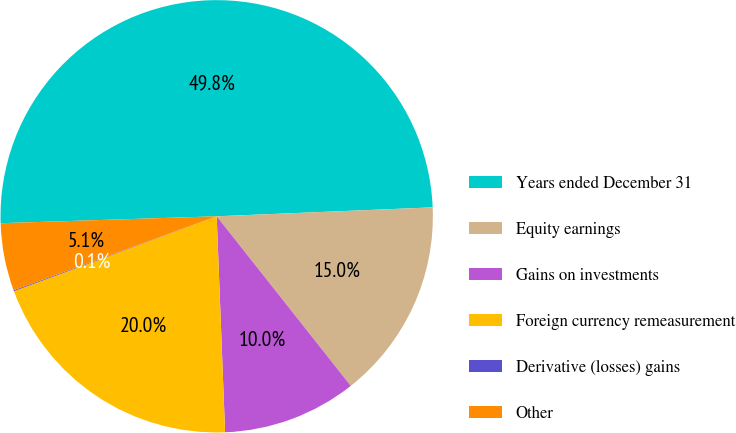<chart> <loc_0><loc_0><loc_500><loc_500><pie_chart><fcel>Years ended December 31<fcel>Equity earnings<fcel>Gains on investments<fcel>Foreign currency remeasurement<fcel>Derivative (losses) gains<fcel>Other<nl><fcel>49.85%<fcel>15.01%<fcel>10.03%<fcel>19.99%<fcel>0.07%<fcel>5.05%<nl></chart> 